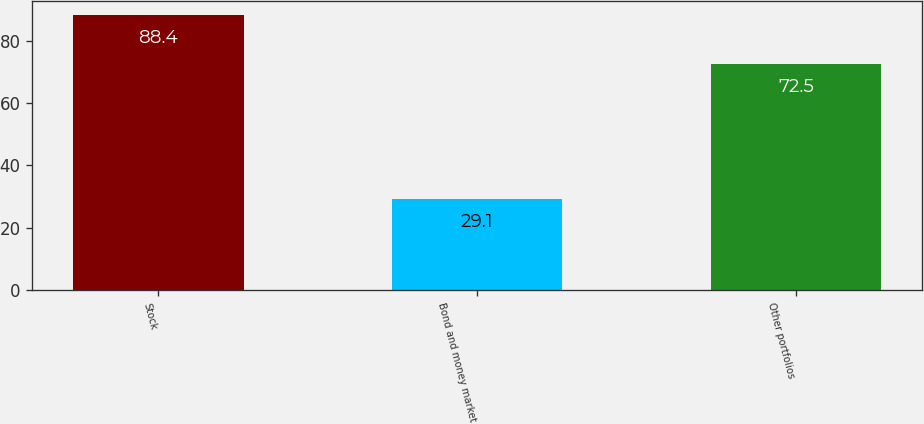Convert chart. <chart><loc_0><loc_0><loc_500><loc_500><bar_chart><fcel>Stock<fcel>Bond and money market<fcel>Other portfolios<nl><fcel>88.4<fcel>29.1<fcel>72.5<nl></chart> 